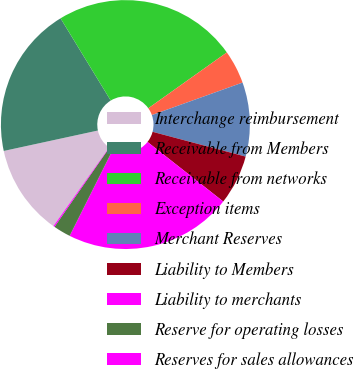Convert chart. <chart><loc_0><loc_0><loc_500><loc_500><pie_chart><fcel>Interchange reimbursement<fcel>Receivable from Members<fcel>Receivable from networks<fcel>Exception items<fcel>Merchant Reserves<fcel>Liability to Members<fcel>Liability to merchants<fcel>Reserve for operating losses<fcel>Reserves for sales allowances<nl><fcel>11.79%<fcel>19.68%<fcel>23.88%<fcel>4.36%<fcel>9.62%<fcel>6.46%<fcel>21.78%<fcel>2.26%<fcel>0.16%<nl></chart> 